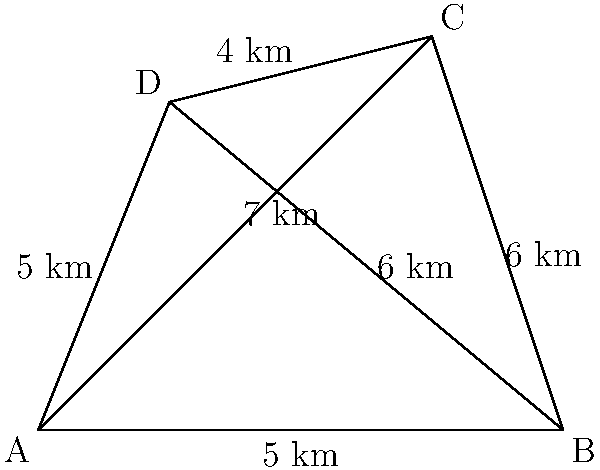During an expedition to map a remote lake for potential ecotourism opportunities, you've collected measurements to calculate its area. The lake's shape can be approximated by the quadrilateral ABCD shown above. Given the distances between the points as labeled, calculate the area of the lake in square kilometers. To find the area of the irregularly shaped lake, we can use the method of triangulation. We'll divide the quadrilateral into two triangles and calculate their areas separately.

Step 1: Divide the quadrilateral into triangles ABC and ACD.

Step 2: Calculate the area of triangle ABC using Heron's formula.
Let $s_1 = \frac{a+b+c}{2}$ be the semi-perimeter of triangle ABC.
$s_1 = \frac{5+6+7}{2} = 9$ km

Area of ABC = $\sqrt{s_1(s_1-a)(s_1-b)(s_1-c)}$
            = $\sqrt{9(9-5)(9-6)(9-7)}$
            = $\sqrt{9 \cdot 4 \cdot 3 \cdot 2}$
            = $\sqrt{216}$
            = 14.70 km²

Step 3: Calculate the area of triangle ACD using Heron's formula.
Let $s_2 = \frac{d+e+f}{2}$ be the semi-perimeter of triangle ACD.
$s_2 = \frac{7+4+5}{2} = 8$ km

Area of ACD = $\sqrt{s_2(s_2-d)(s_2-e)(s_2-f)}$
            = $\sqrt{8(8-7)(8-4)(8-5)}$
            = $\sqrt{8 \cdot 1 \cdot 4 \cdot 3}$
            = $\sqrt{96}$
            = 9.80 km²

Step 4: Sum the areas of both triangles.
Total area = Area of ABC + Area of ACD
           = 14.70 + 9.80
           = 24.50 km²

Therefore, the area of the lake is approximately 24.50 square kilometers.
Answer: 24.50 km² 